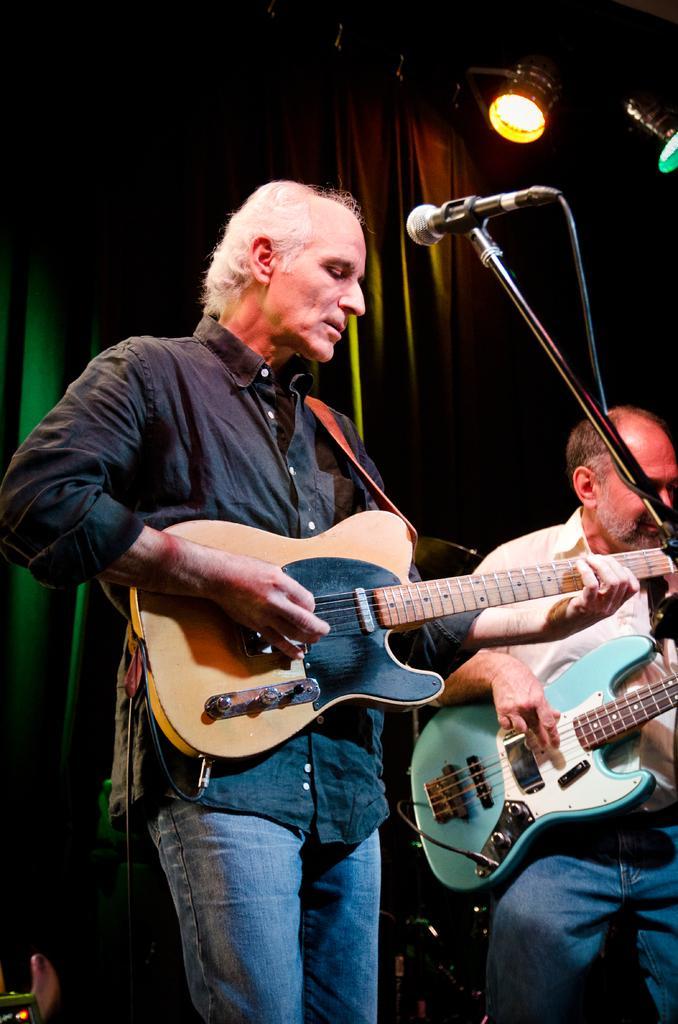How would you summarize this image in a sentence or two? In this picture we can see two people are playing guitar in front of microphone, in the background we can see curtain and couple of lights. 